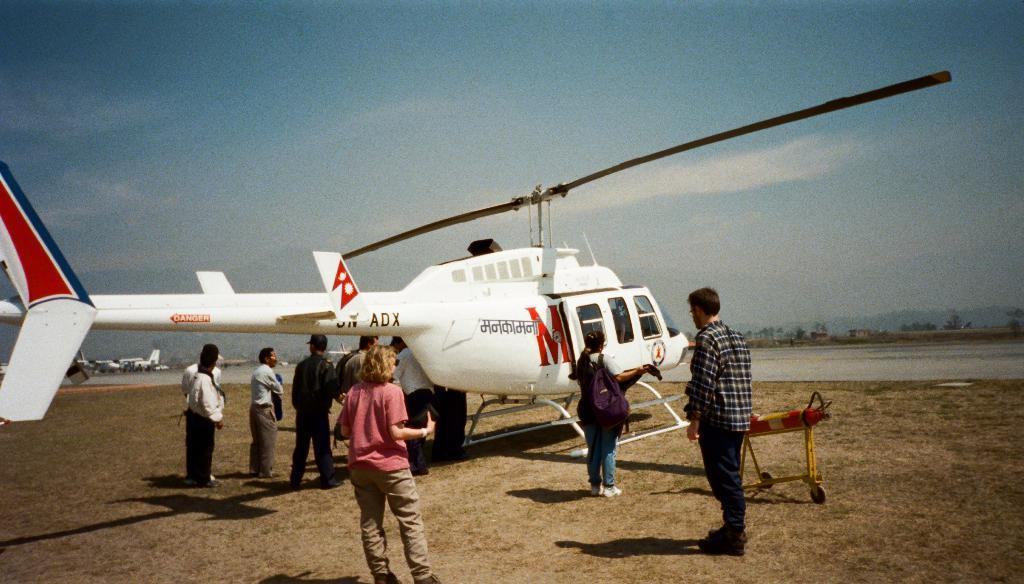<image>
Summarize the visual content of the image. A group of people standing around a white helicopter that has a large red M on one side. 